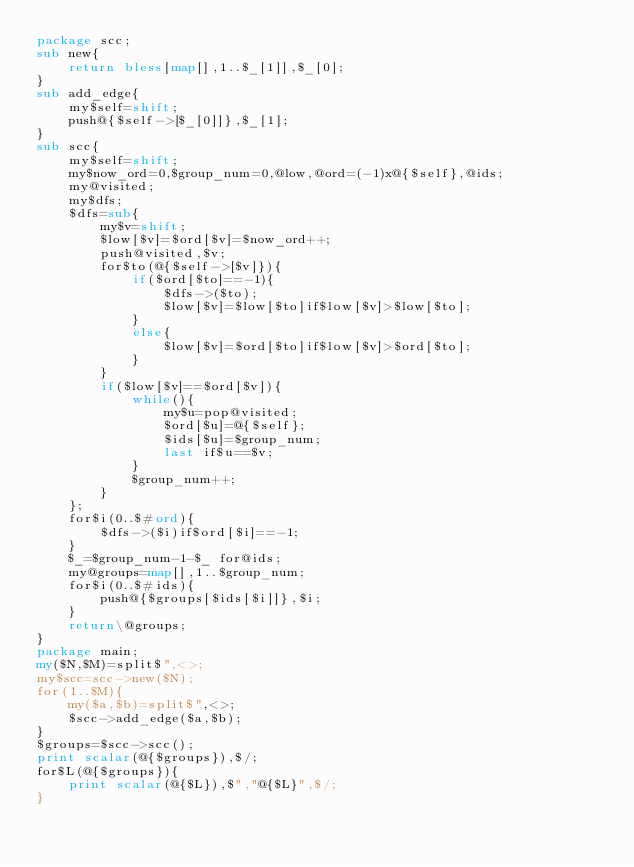Convert code to text. <code><loc_0><loc_0><loc_500><loc_500><_Perl_>package scc;
sub new{
	return bless[map[],1..$_[1]],$_[0];
}
sub add_edge{
	my$self=shift;
	push@{$self->[$_[0]]},$_[1];
}
sub scc{
	my$self=shift;
	my$now_ord=0,$group_num=0,@low,@ord=(-1)x@{$self},@ids;
	my@visited;
	my$dfs;
	$dfs=sub{
		my$v=shift;
		$low[$v]=$ord[$v]=$now_ord++;
		push@visited,$v;
		for$to(@{$self->[$v]}){
			if($ord[$to]==-1){
				$dfs->($to);
				$low[$v]=$low[$to]if$low[$v]>$low[$to];
			}
			else{
				$low[$v]=$ord[$to]if$low[$v]>$ord[$to];
			}
		}
		if($low[$v]==$ord[$v]){
			while(){
				my$u=pop@visited;
				$ord[$u]=@{$self};
				$ids[$u]=$group_num;
				last if$u==$v;
			}
			$group_num++;
		}
	};
	for$i(0..$#ord){
		$dfs->($i)if$ord[$i]==-1;
	}
	$_=$group_num-1-$_ for@ids;
	my@groups=map[],1..$group_num;
	for$i(0..$#ids){
		push@{$groups[$ids[$i]]},$i;
	}
	return\@groups;
}
package main;
my($N,$M)=split$",<>;
my$scc=scc->new($N);
for(1..$M){
	my($a,$b)=split$",<>;
	$scc->add_edge($a,$b);
}
$groups=$scc->scc();
print scalar(@{$groups}),$/;
for$L(@{$groups}){
	print scalar(@{$L}),$","@{$L}",$/;
}
</code> 